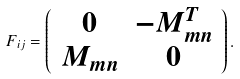Convert formula to latex. <formula><loc_0><loc_0><loc_500><loc_500>F _ { i j } = \left ( \begin{array} { c c } 0 & - M ^ { T } _ { m n } \\ M _ { m n } & 0 \end{array} \right ) .</formula> 